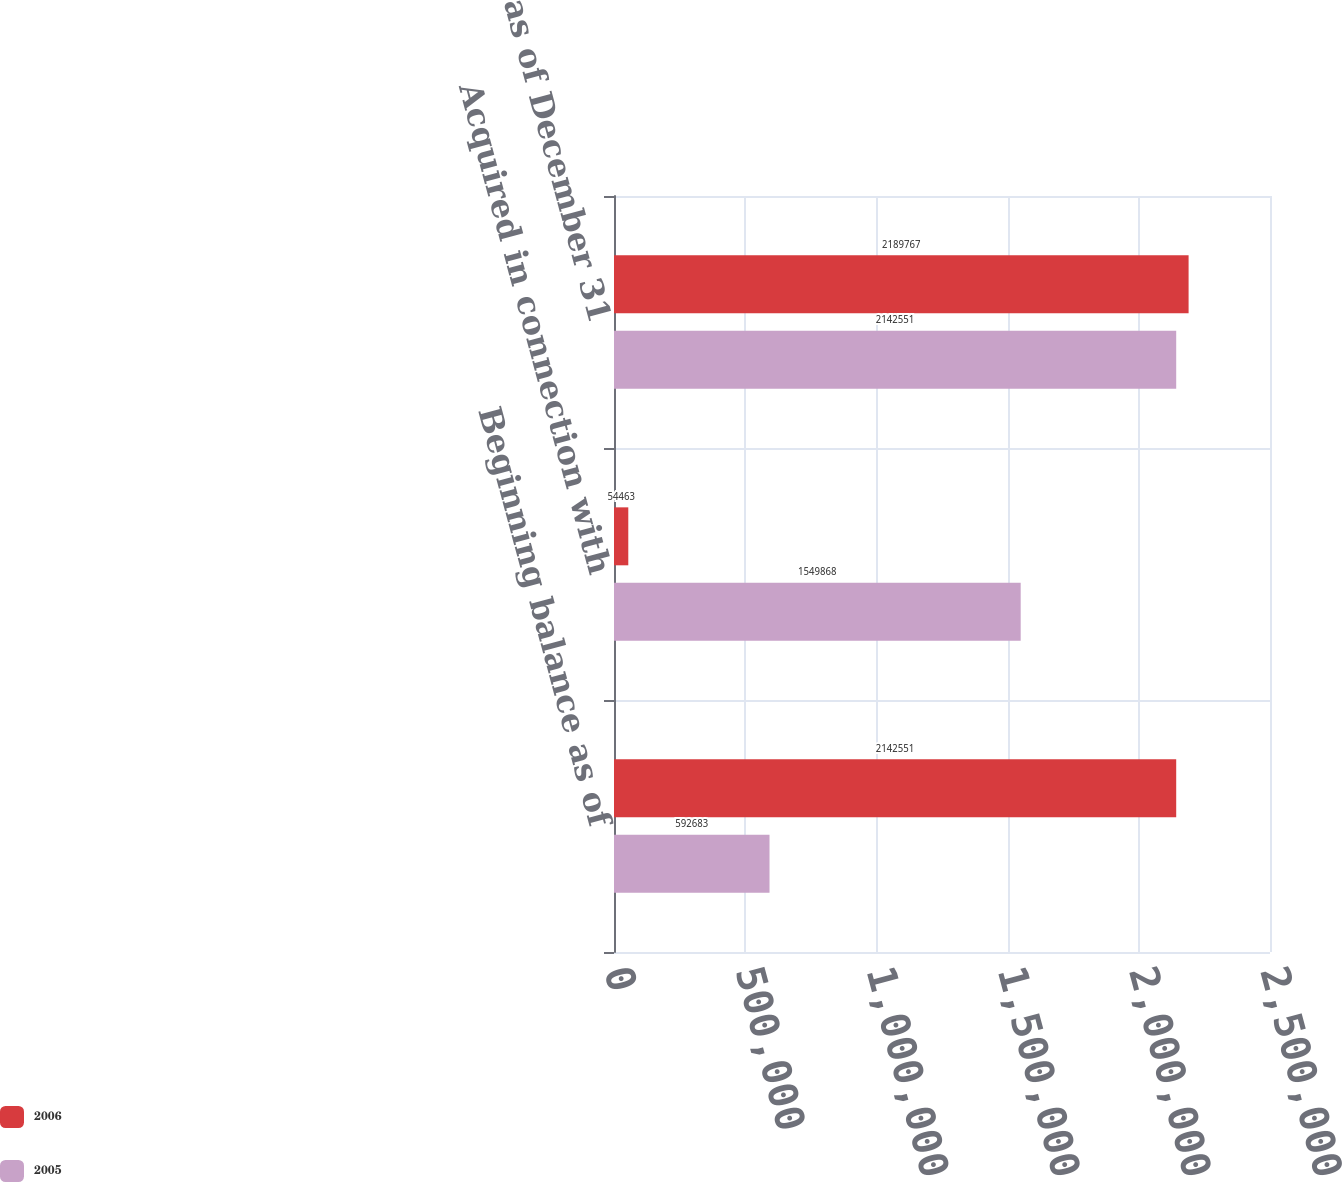Convert chart to OTSL. <chart><loc_0><loc_0><loc_500><loc_500><stacked_bar_chart><ecel><fcel>Beginning balance as of<fcel>Acquired in connection with<fcel>Balance as of December 31<nl><fcel>2006<fcel>2.14255e+06<fcel>54463<fcel>2.18977e+06<nl><fcel>2005<fcel>592683<fcel>1.54987e+06<fcel>2.14255e+06<nl></chart> 